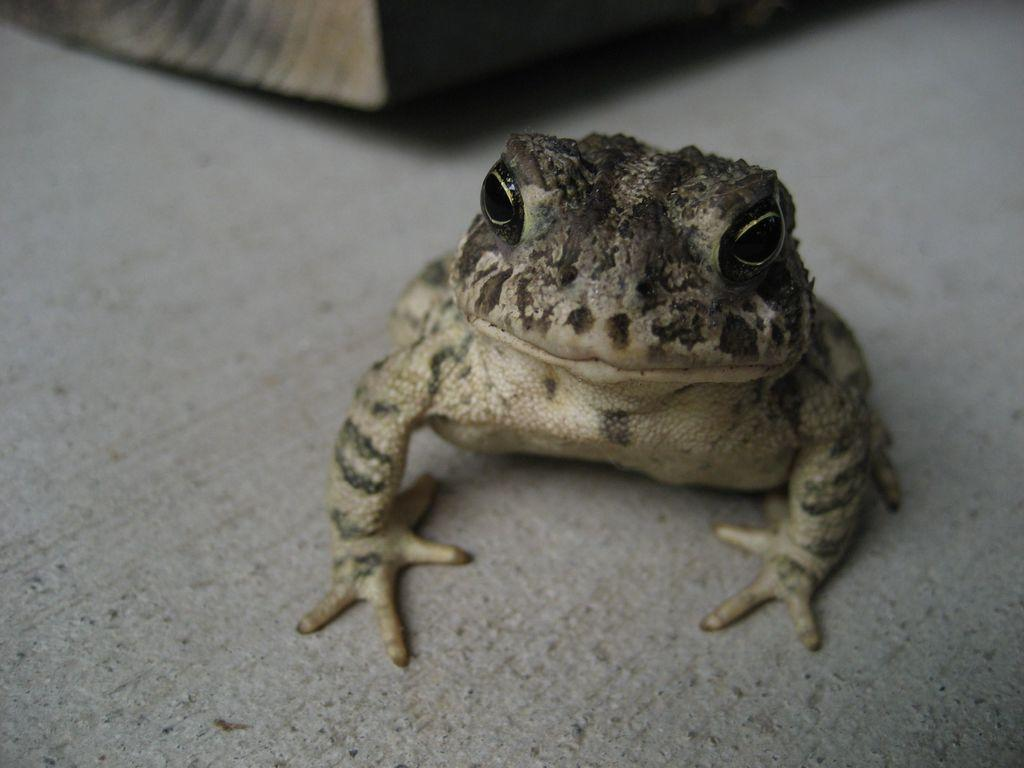What type of animal is present on the surface in the image? There is a frog on the surface in the image. What can be observed about the top part of the image? The top of the image has a blurry view. Can you describe any objects that are visible in the image? There are objects visible in the image, but their specific details are not clear due to the blurry view. What type of religious ceremony is taking place in the image? There is no indication of a religious ceremony in the image; it features a frog on a surface with a blurry view at the top. 